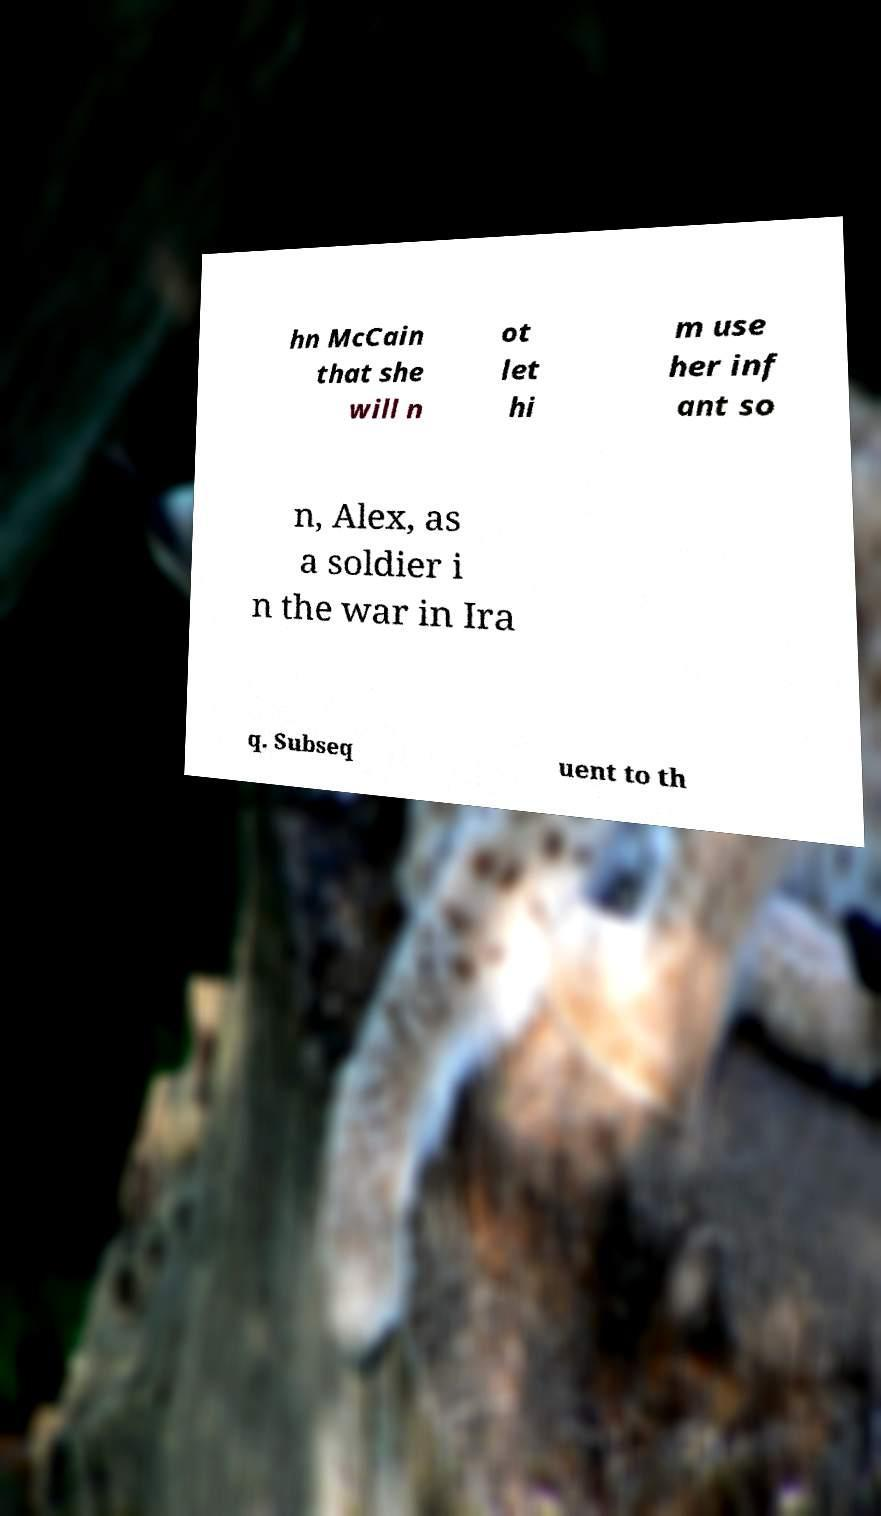Please identify and transcribe the text found in this image. hn McCain that she will n ot let hi m use her inf ant so n, Alex, as a soldier i n the war in Ira q. Subseq uent to th 